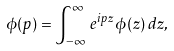<formula> <loc_0><loc_0><loc_500><loc_500>\phi ( p ) = \int _ { - \infty } ^ { \infty } \, e ^ { i p z } \, \phi ( z ) \, d z ,</formula> 